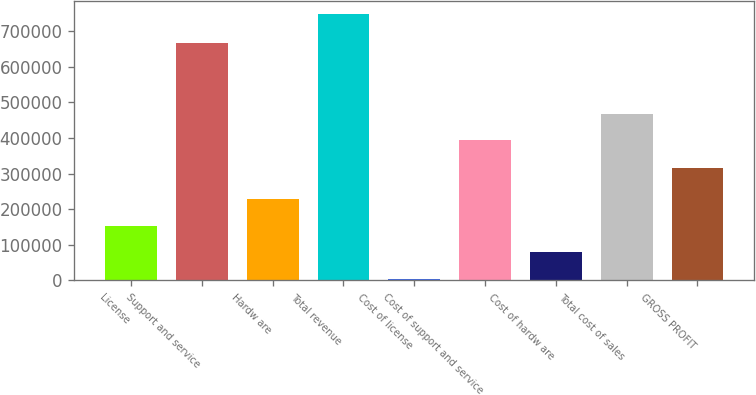Convert chart. <chart><loc_0><loc_0><loc_500><loc_500><bar_chart><fcel>License<fcel>Support and service<fcel>Hardw are<fcel>Total revenue<fcel>Cost of license<fcel>Cost of support and service<fcel>Cost of hardw are<fcel>Total cost of sales<fcel>GROSS PROFIT<nl><fcel>153385<fcel>665297<fcel>227573<fcel>746892<fcel>5008<fcel>394040<fcel>79196.4<fcel>468228<fcel>315994<nl></chart> 